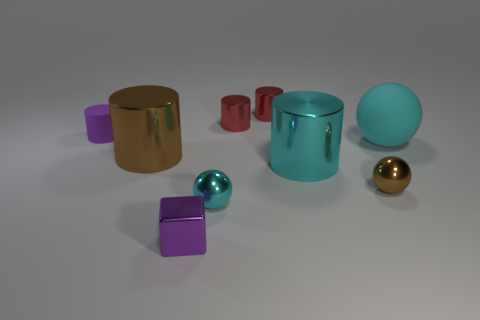Subtract all brown cylinders. How many cylinders are left? 4 Subtract all tiny matte cylinders. How many cylinders are left? 4 Subtract all green cylinders. Subtract all purple blocks. How many cylinders are left? 5 Add 1 brown metal objects. How many objects exist? 10 Subtract all spheres. How many objects are left? 6 Add 3 small cyan cylinders. How many small cyan cylinders exist? 3 Subtract 0 cyan blocks. How many objects are left? 9 Subtract all big cyan rubber objects. Subtract all small purple rubber cylinders. How many objects are left? 7 Add 9 metal cubes. How many metal cubes are left? 10 